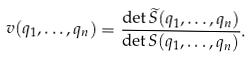<formula> <loc_0><loc_0><loc_500><loc_500>v ( q _ { 1 } , \dots , q _ { n } ) = \frac { \det \widetilde { S } ( q _ { 1 } , \dots , q _ { n } ) } { \det { S } ( q _ { 1 } , \dots , q _ { n } ) } .</formula> 